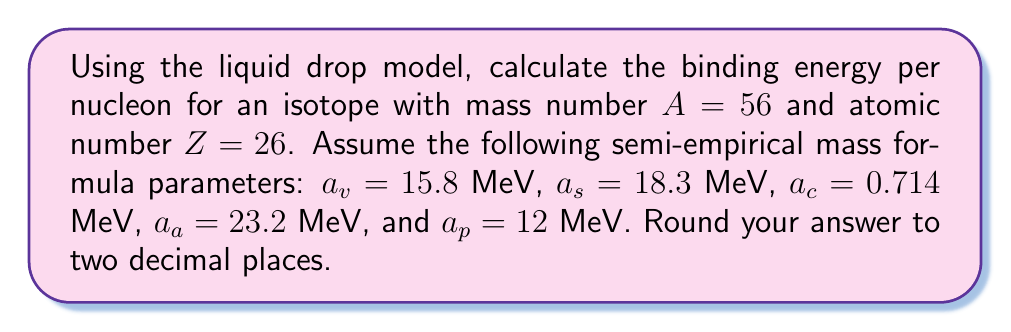What is the answer to this math problem? To solve this problem, we'll use the semi-empirical mass formula (SEMF) based on the liquid drop model. The binding energy $B(A,Z)$ is given by:

$$B(A,Z) = a_v A - a_s A^{2/3} - a_c \frac{Z(Z-1)}{A^{1/3}} - a_a \frac{(A-2Z)^2}{A} + \delta(A,Z)$$

Where $\delta(A,Z)$ is the pairing term:
$$\delta(A,Z) = \begin{cases}
+a_p A^{-3/4} & \text{for even-even nuclei} \\
-a_p A^{-3/4} & \text{for odd-odd nuclei} \\
0 & \text{for odd-A nuclei}
\end{cases}$$

For $A = 56$ and $Z = 26$ (Fe-56), we have an even-even nucleus.

Step 1: Calculate each term in the SEMF:
1. Volume term: $a_v A = 15.8 \times 56 = 884.8$ MeV
2. Surface term: $a_s A^{2/3} = 18.3 \times 56^{2/3} = 240.39$ MeV
3. Coulomb term: $a_c \frac{Z(Z-1)}{A^{1/3}} = 0.714 \times \frac{26(25)}{56^{1/3}} = 179.04$ MeV
4. Asymmetry term: $a_a \frac{(A-2Z)^2}{A} = 23.2 \times \frac{(56-2(26))^2}{56} = 23.2$ MeV
5. Pairing term: $\delta(A,Z) = a_p A^{-3/4} = 12 \times 56^{-3/4} = 0.65$ MeV

Step 2: Sum up all terms to get the total binding energy:
$$B(A,Z) = 884.8 - 240.39 - 179.04 - 23.2 + 0.65 = 442.82 \text{ MeV}$$

Step 3: Calculate the binding energy per nucleon:
$$\frac{B(A,Z)}{A} = \frac{442.82}{56} = 7.91 \text{ MeV/nucleon}$$

Rounding to two decimal places, we get 7.91 MeV/nucleon.
Answer: 7.91 MeV/nucleon 